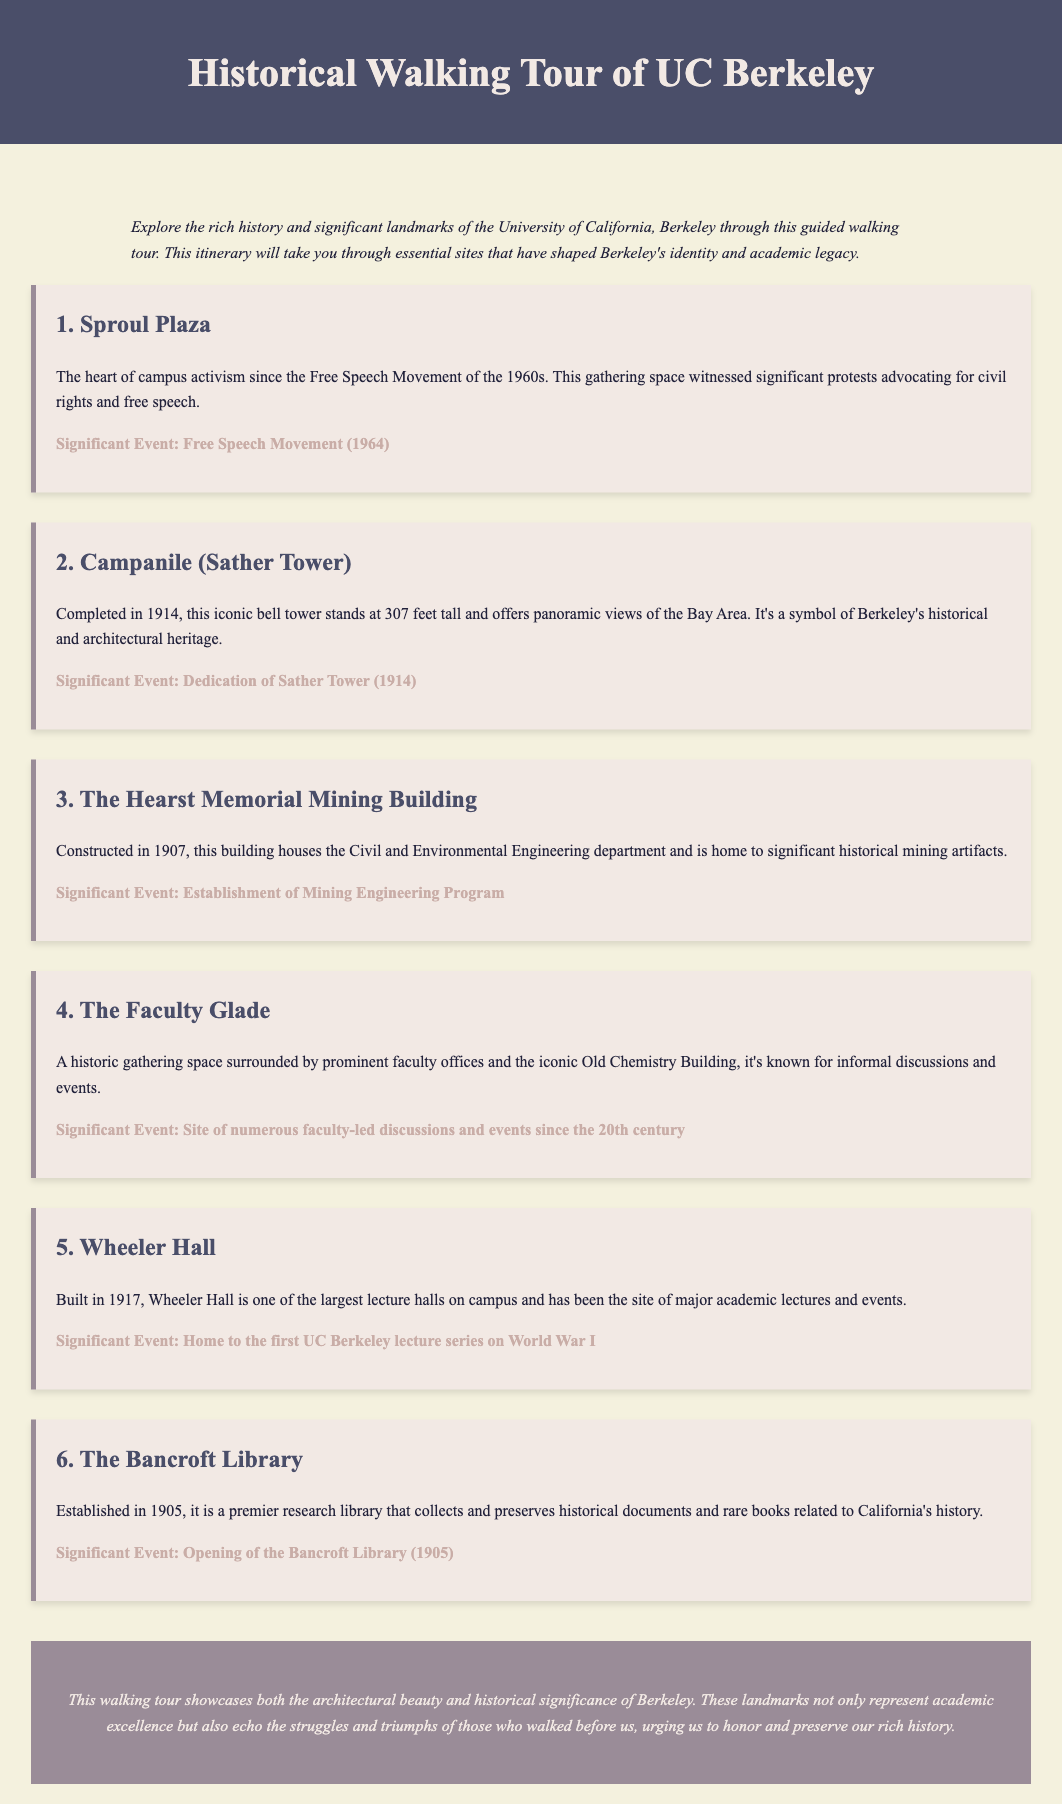What significant movement took place at Sproul Plaza? Sproul Plaza is associated with the Free Speech Movement, which was a pivotal event in the 1960s for civil rights and free speech.
Answer: Free Speech Movement What year was the Campanile completed? The document states that the Campanile (Sather Tower) was completed in 1914.
Answer: 1914 Which building was constructed in 1907? The Hearst Memorial Mining Building was built in 1907, according to the itinerary.
Answer: Hearst Memorial Mining Building What is the primary function of The Bancroft Library? The Bancroft Library is described as a research library that collects and preserves historical documents and rare books.
Answer: Research library In what year did the Bancroft Library open? The opening of the Bancroft Library is noted to have occurred in 1905.
Answer: 1905 How many significant events are listed for Wheeler Hall? Wheeler Hall has one significant event listed regarding its role in the first UC Berkeley lecture series on World War I.
Answer: One What major historical feature is highlighted at The Faculty Glade? The Faculty Glade is recognized for being a site of numerous faculty-led discussions and events since the 20th century.
Answer: Discussions and events What does the conclusion emphasize about Berkeley’s history? The conclusion emphasizes the importance of honoring and preserving Berkeley's rich history and significant struggles.
Answer: Honoring history 